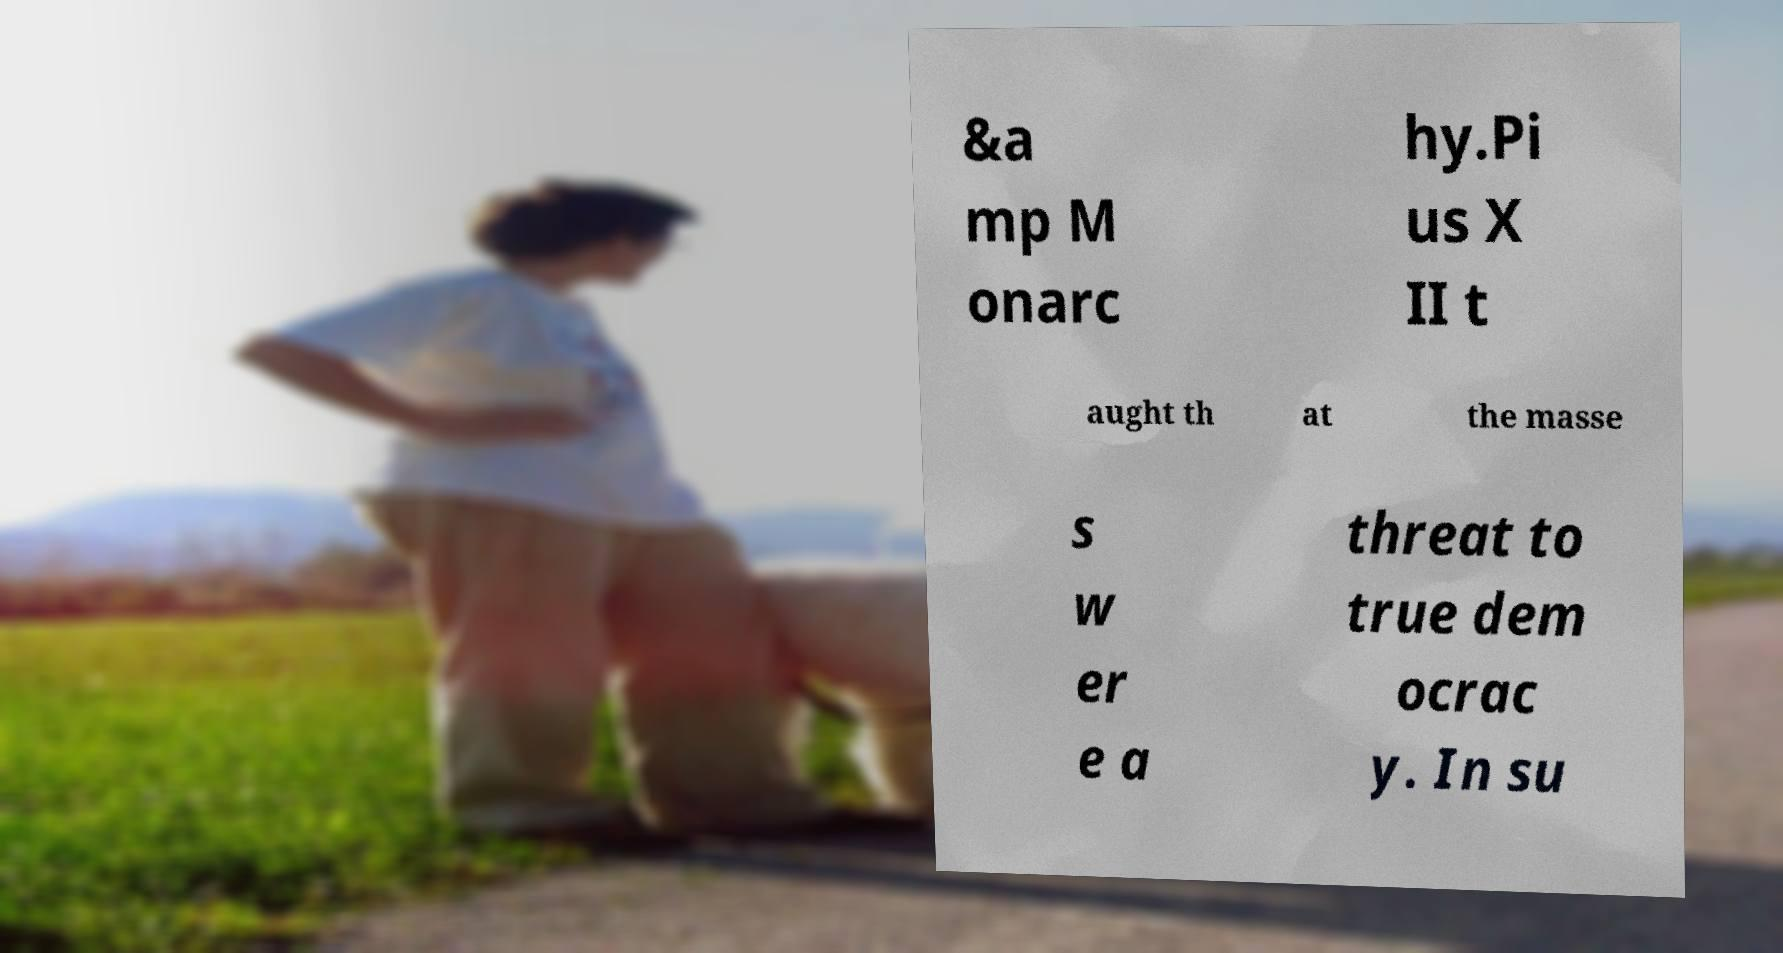Can you read and provide the text displayed in the image?This photo seems to have some interesting text. Can you extract and type it out for me? &a mp M onarc hy.Pi us X II t aught th at the masse s w er e a threat to true dem ocrac y. In su 